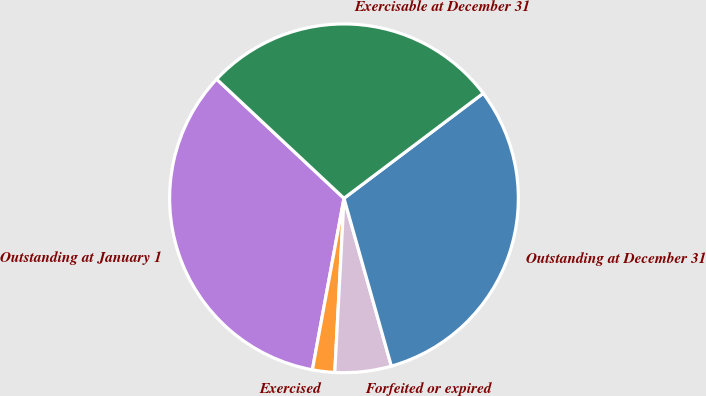Convert chart to OTSL. <chart><loc_0><loc_0><loc_500><loc_500><pie_chart><fcel>Outstanding at January 1<fcel>Exercised<fcel>Forfeited or expired<fcel>Outstanding at December 31<fcel>Exercisable at December 31<nl><fcel>34.07%<fcel>2.06%<fcel>5.22%<fcel>30.9%<fcel>27.74%<nl></chart> 